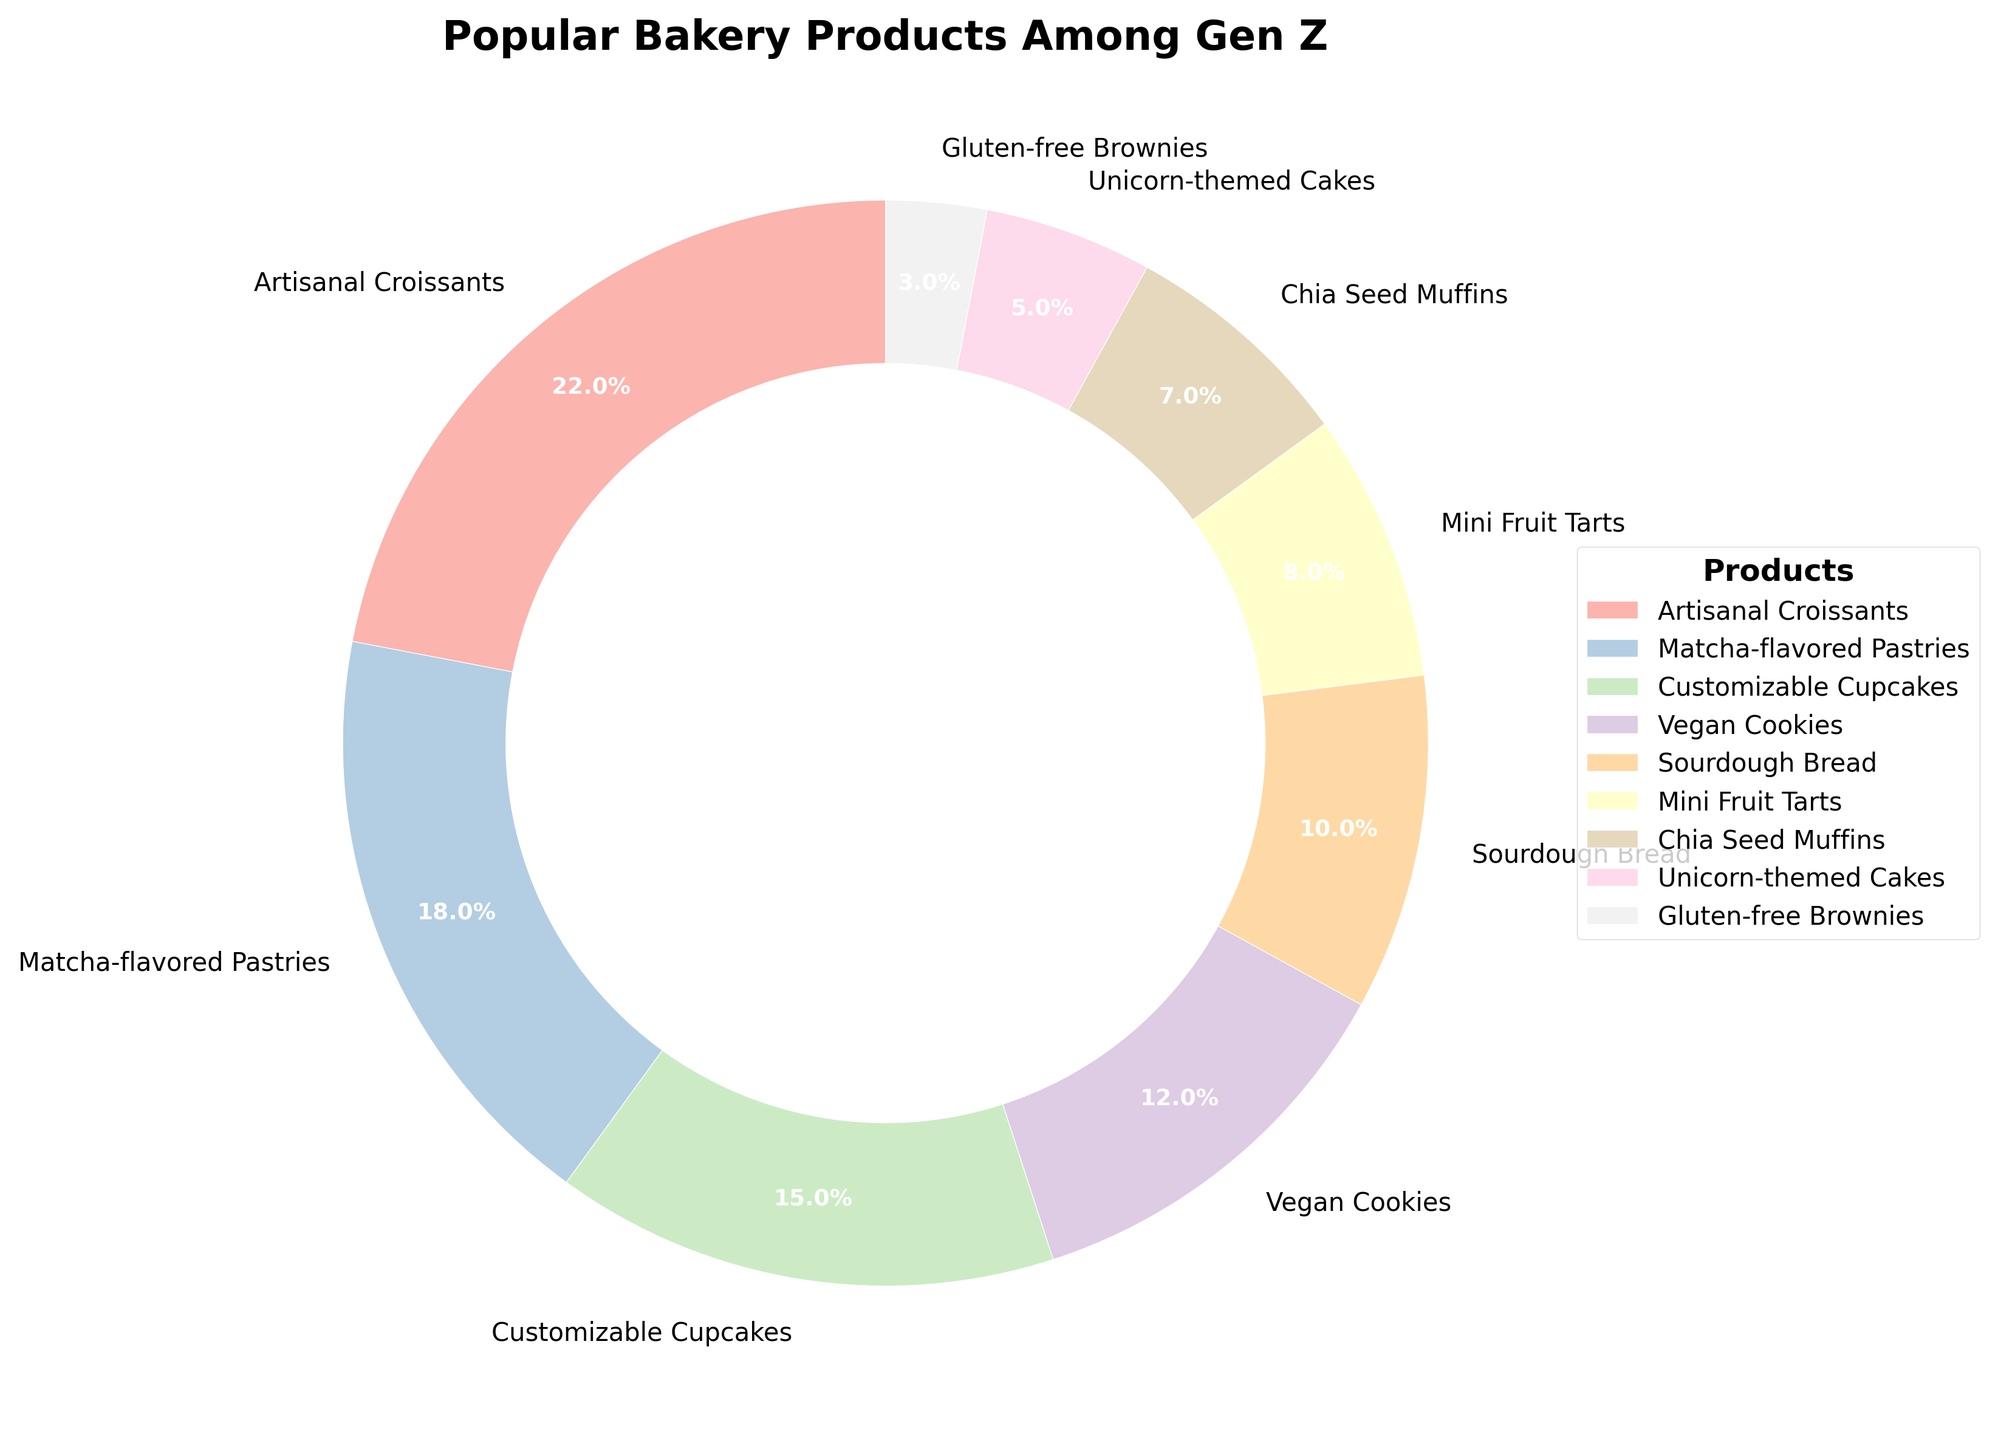What is the most popular bakery product among Gen Z customers? The segment with the largest percentage represents the most popular product. The Artisanal Croissants have the highest percentage (22%) in the pie chart.
Answer: Artisanal Croissants Which product type is less popular: Vegan Cookies or Mini Fruit Tarts? By comparing the two percentages directly from the chart, Vegan Cookies have a lower percentage (12%) compared to Mini Fruit Tarts (8%).
Answer: Mini Fruit Tarts What is the total percentage of Matcha-flavored Pastries and Customizable Cupcakes combined? To find the total percentage, add the values of Matcha-flavored Pastries (18%) and Customizable Cupcakes (15%). 18% + 15% = 33%.
Answer: 33% How many percent more popular are Artisanal Croissants than Sourdough Bread? To determine this, subtract the percentage of Sourdough Bread (10%) from the percentage of Artisanal Croissants (22%). 22% - 10% = 12%.
Answer: 12% Which product has the smallest representation in the pie chart? The segment with the smallest percentage denotes the least popular product. Gluten-free Brownies have the smallest percentage, which is 3%.
Answer: Gluten-free Brownies Are Customizable Cupcakes more popular than Sourdough Bread and Vegan Cookies combined? First, sum the percentages of Sourdough Bread (10%) and Vegan Cookies (12%) to get 22%. Customizable Cupcakes have a percentage of 15%, which is less than 22%.
Answer: No List the products that have a percentage lower than 10%. The products with percentages lower than 10% are Mini Fruit Tarts (8%), Chia Seed Muffins (7%), Unicorn-themed Cakes (5%), and Gluten-free Brownies (3%).
Answer: Mini Fruit Tarts, Chia Seed Muffins, Unicorn-themed Cakes, Gluten-free Brownies Which product category is represented with a wedge of the color that's visually closest to white (lightest shade)? The product with the wedge in the lightest color (depending on the color scheme used, typically the lightest pastel color at the start of the colormap) is likely Artisanal Croissants as it is often the first in the sequence.
Answer: Artisanal Croissants What percentage of products other than Artisanal Croissants falls into the pie chart? Subtract the percentage of Artisanal Croissants (22%) from the total percentage (100%) to get the remaining percentage. 100% - 22% = 78%.
Answer: 78% What is the visual appearance (color) of the segment representing Chia Seed Muffins? Identify the color used in the Chia Seed Muffins segment. By checking its position, it is likely a light pastel color used according to a pastel colormap (typically a beige or light brown).
Answer: Light pastel color 